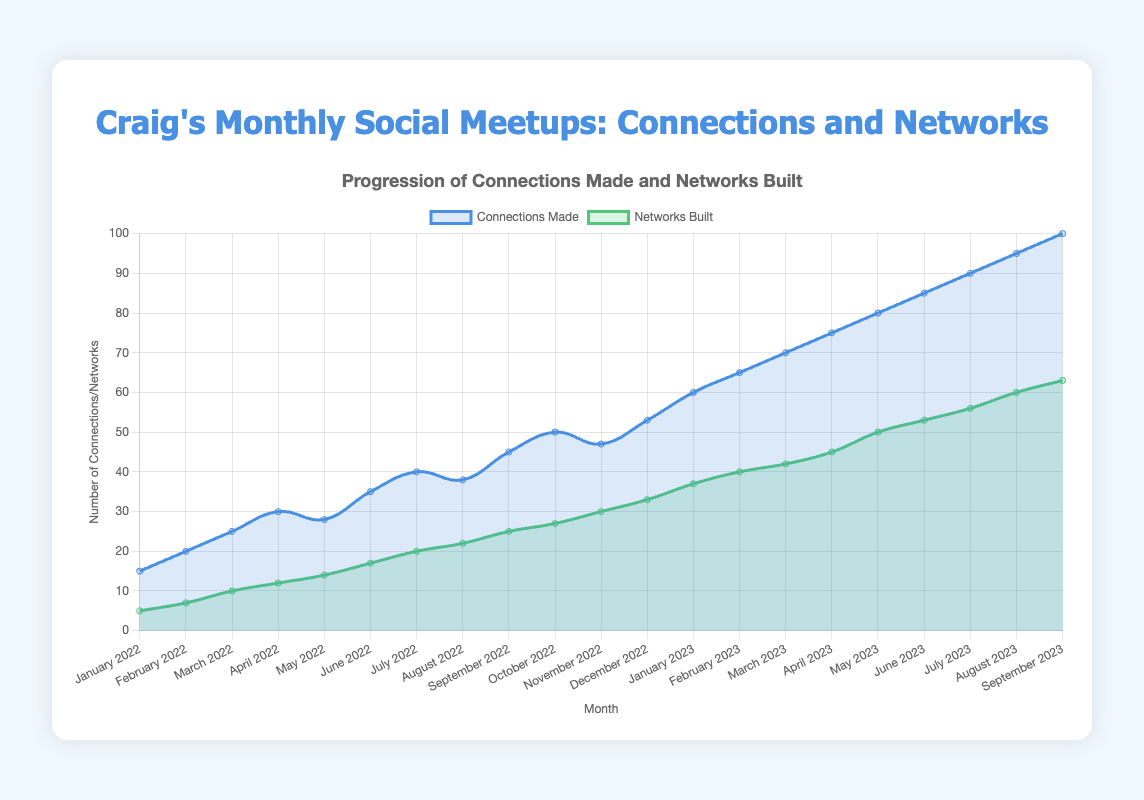How many connections were made in total from January 2022 to September 2023? To find the total number of connections, sum the "connections_made" values for each month from January 2022 to September 2023. This is 15 + 20 + 25 + 30 + 28 + 35 + 40 + 38 + 45 + 50 + 47 + 53 + 60 + 65 + 70 + 75 + 80 + 85 + 90 + 95 + 100 = 1,096.
Answer: 1,096 Comparing March 2022 and March 2023, in which month were more networks built, and by how much? In March 2022, 10 networks were built. In March 2023, 42 networks were built. The difference is 42 - 10 = 32. So, 32 more networks were built in March 2023 than in March 2022.
Answer: March 2023, by 32 What is the average number of networks built per month in 2022? To find the average number of networks built per month in 2022, sum the "networks_built" values for each month in 2022 and then divide by 12. This is (5 + 7 + 10 + 12 + 14 + 17 + 20 + 22 + 25 + 27 + 30 + 33)/12 = 222/12 = 18.5.
Answer: 18.5 Which month saw the highest number of connections made and what was the value? The highest number of connections made was in September 2023 with 100 connections. By visually inspecting the chart, September 2023 is the peak point on the "Connections Made" line.
Answer: September 2023, 100 What is the difference in the number of networks built between December 2022 and January 2023? In December 2022, 33 networks were built. In January 2023, 37 networks were built. The difference is 37 - 33 = 4.
Answer: 4 How many more networks were built in June 2023 compared to June 2022? In June 2023, 53 networks were built. In June 2022, 17 networks were built. The difference is 53 - 17 = 36.
Answer: 36 Over which months did both the number of connections made and the number of networks built increase consistently? By examining the trendlines in the chart, we can see that the number of connections made and the number of networks built increased consistently from January 2022 to September 2023. Both lines show a steady upward trend during this period.
Answer: January 2022 to September 2023 Which line in the chart is represented by the green color? By looking at the color coding in the chart legend, the green color represents the "Networks Built" data series.
Answer: Networks Built Calculate the average growth in connections made per month from January 2022 to September 2023. First, find the total increase in connections made from January 2022 (15) to September 2023 (100), which is 100 - 15 = 85. Since this period covers 21 months, the average monthly growth is 85/21 ≈ 4.05.
Answer: 4.05 